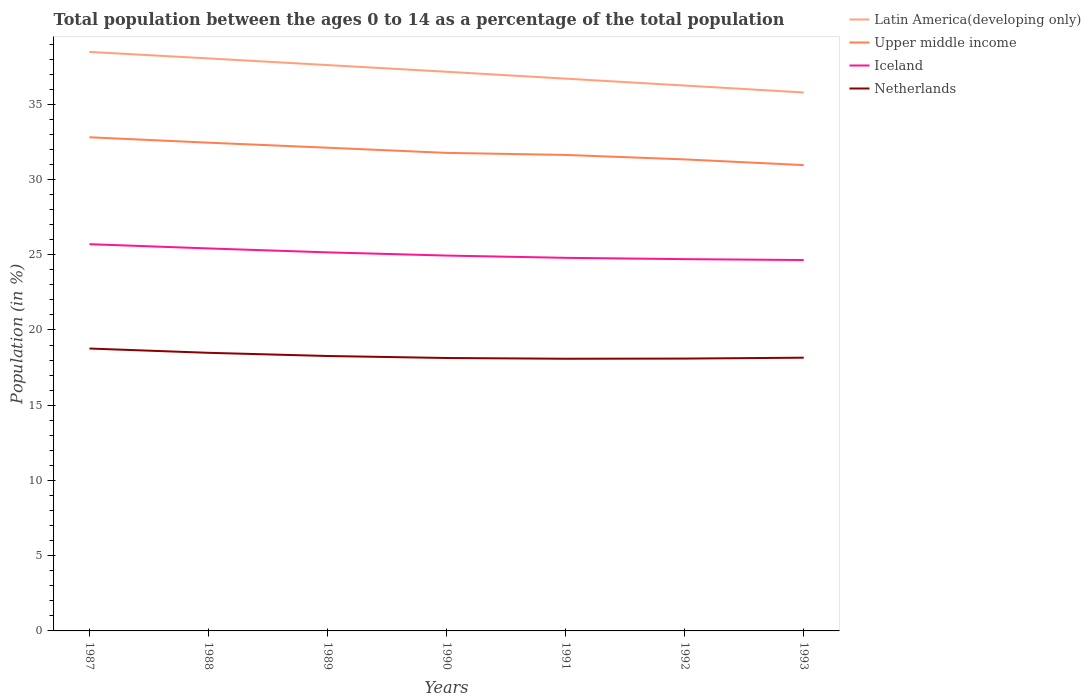Does the line corresponding to Latin America(developing only) intersect with the line corresponding to Iceland?
Offer a terse response. No. Is the number of lines equal to the number of legend labels?
Keep it short and to the point. Yes. Across all years, what is the maximum percentage of the population ages 0 to 14 in Netherlands?
Your response must be concise. 18.09. What is the total percentage of the population ages 0 to 14 in Iceland in the graph?
Ensure brevity in your answer.  0.21. What is the difference between the highest and the second highest percentage of the population ages 0 to 14 in Iceland?
Give a very brief answer. 1.05. Is the percentage of the population ages 0 to 14 in Iceland strictly greater than the percentage of the population ages 0 to 14 in Latin America(developing only) over the years?
Ensure brevity in your answer.  Yes. How many years are there in the graph?
Make the answer very short. 7. Does the graph contain any zero values?
Your response must be concise. No. Does the graph contain grids?
Offer a terse response. No. Where does the legend appear in the graph?
Give a very brief answer. Top right. How many legend labels are there?
Your response must be concise. 4. How are the legend labels stacked?
Keep it short and to the point. Vertical. What is the title of the graph?
Ensure brevity in your answer.  Total population between the ages 0 to 14 as a percentage of the total population. Does "North America" appear as one of the legend labels in the graph?
Your answer should be very brief. No. What is the label or title of the X-axis?
Your answer should be compact. Years. What is the Population (in %) in Latin America(developing only) in 1987?
Your response must be concise. 38.48. What is the Population (in %) of Upper middle income in 1987?
Ensure brevity in your answer.  32.81. What is the Population (in %) in Iceland in 1987?
Offer a very short reply. 25.7. What is the Population (in %) of Netherlands in 1987?
Provide a short and direct response. 18.77. What is the Population (in %) of Latin America(developing only) in 1988?
Your answer should be very brief. 38.05. What is the Population (in %) in Upper middle income in 1988?
Ensure brevity in your answer.  32.45. What is the Population (in %) in Iceland in 1988?
Make the answer very short. 25.42. What is the Population (in %) in Netherlands in 1988?
Offer a terse response. 18.48. What is the Population (in %) in Latin America(developing only) in 1989?
Your answer should be compact. 37.61. What is the Population (in %) of Upper middle income in 1989?
Offer a terse response. 32.11. What is the Population (in %) of Iceland in 1989?
Your answer should be very brief. 25.16. What is the Population (in %) in Netherlands in 1989?
Offer a very short reply. 18.27. What is the Population (in %) in Latin America(developing only) in 1990?
Give a very brief answer. 37.16. What is the Population (in %) of Upper middle income in 1990?
Provide a succinct answer. 31.77. What is the Population (in %) of Iceland in 1990?
Ensure brevity in your answer.  24.95. What is the Population (in %) of Netherlands in 1990?
Provide a succinct answer. 18.14. What is the Population (in %) of Latin America(developing only) in 1991?
Give a very brief answer. 36.7. What is the Population (in %) in Upper middle income in 1991?
Give a very brief answer. 31.63. What is the Population (in %) of Iceland in 1991?
Your response must be concise. 24.79. What is the Population (in %) of Netherlands in 1991?
Provide a succinct answer. 18.09. What is the Population (in %) in Latin America(developing only) in 1992?
Offer a terse response. 36.25. What is the Population (in %) in Upper middle income in 1992?
Give a very brief answer. 31.34. What is the Population (in %) in Iceland in 1992?
Provide a succinct answer. 24.71. What is the Population (in %) in Netherlands in 1992?
Your response must be concise. 18.1. What is the Population (in %) of Latin America(developing only) in 1993?
Provide a short and direct response. 35.78. What is the Population (in %) of Upper middle income in 1993?
Offer a very short reply. 30.96. What is the Population (in %) in Iceland in 1993?
Give a very brief answer. 24.65. What is the Population (in %) in Netherlands in 1993?
Give a very brief answer. 18.16. Across all years, what is the maximum Population (in %) of Latin America(developing only)?
Your answer should be very brief. 38.48. Across all years, what is the maximum Population (in %) in Upper middle income?
Offer a very short reply. 32.81. Across all years, what is the maximum Population (in %) of Iceland?
Your answer should be very brief. 25.7. Across all years, what is the maximum Population (in %) of Netherlands?
Offer a terse response. 18.77. Across all years, what is the minimum Population (in %) of Latin America(developing only)?
Keep it short and to the point. 35.78. Across all years, what is the minimum Population (in %) in Upper middle income?
Keep it short and to the point. 30.96. Across all years, what is the minimum Population (in %) in Iceland?
Provide a succinct answer. 24.65. Across all years, what is the minimum Population (in %) in Netherlands?
Ensure brevity in your answer.  18.09. What is the total Population (in %) of Latin America(developing only) in the graph?
Your response must be concise. 260.03. What is the total Population (in %) of Upper middle income in the graph?
Ensure brevity in your answer.  223.07. What is the total Population (in %) of Iceland in the graph?
Ensure brevity in your answer.  175.38. What is the total Population (in %) of Netherlands in the graph?
Provide a succinct answer. 128.01. What is the difference between the Population (in %) in Latin America(developing only) in 1987 and that in 1988?
Your answer should be very brief. 0.43. What is the difference between the Population (in %) of Upper middle income in 1987 and that in 1988?
Offer a terse response. 0.36. What is the difference between the Population (in %) in Iceland in 1987 and that in 1988?
Your response must be concise. 0.28. What is the difference between the Population (in %) in Netherlands in 1987 and that in 1988?
Provide a short and direct response. 0.28. What is the difference between the Population (in %) of Latin America(developing only) in 1987 and that in 1989?
Keep it short and to the point. 0.87. What is the difference between the Population (in %) in Upper middle income in 1987 and that in 1989?
Offer a terse response. 0.69. What is the difference between the Population (in %) of Iceland in 1987 and that in 1989?
Make the answer very short. 0.54. What is the difference between the Population (in %) of Netherlands in 1987 and that in 1989?
Ensure brevity in your answer.  0.5. What is the difference between the Population (in %) of Latin America(developing only) in 1987 and that in 1990?
Your response must be concise. 1.32. What is the difference between the Population (in %) in Upper middle income in 1987 and that in 1990?
Provide a succinct answer. 1.04. What is the difference between the Population (in %) in Iceland in 1987 and that in 1990?
Your answer should be very brief. 0.76. What is the difference between the Population (in %) of Netherlands in 1987 and that in 1990?
Your response must be concise. 0.63. What is the difference between the Population (in %) in Latin America(developing only) in 1987 and that in 1991?
Ensure brevity in your answer.  1.78. What is the difference between the Population (in %) of Upper middle income in 1987 and that in 1991?
Give a very brief answer. 1.17. What is the difference between the Population (in %) in Iceland in 1987 and that in 1991?
Keep it short and to the point. 0.91. What is the difference between the Population (in %) of Netherlands in 1987 and that in 1991?
Provide a succinct answer. 0.68. What is the difference between the Population (in %) in Latin America(developing only) in 1987 and that in 1992?
Give a very brief answer. 2.23. What is the difference between the Population (in %) of Upper middle income in 1987 and that in 1992?
Give a very brief answer. 1.47. What is the difference between the Population (in %) in Iceland in 1987 and that in 1992?
Provide a short and direct response. 1. What is the difference between the Population (in %) in Netherlands in 1987 and that in 1992?
Ensure brevity in your answer.  0.67. What is the difference between the Population (in %) of Latin America(developing only) in 1987 and that in 1993?
Your answer should be compact. 2.7. What is the difference between the Population (in %) of Upper middle income in 1987 and that in 1993?
Provide a succinct answer. 1.85. What is the difference between the Population (in %) in Iceland in 1987 and that in 1993?
Provide a succinct answer. 1.05. What is the difference between the Population (in %) in Netherlands in 1987 and that in 1993?
Your answer should be very brief. 0.61. What is the difference between the Population (in %) of Latin America(developing only) in 1988 and that in 1989?
Offer a very short reply. 0.44. What is the difference between the Population (in %) of Upper middle income in 1988 and that in 1989?
Provide a short and direct response. 0.33. What is the difference between the Population (in %) in Iceland in 1988 and that in 1989?
Offer a very short reply. 0.26. What is the difference between the Population (in %) of Netherlands in 1988 and that in 1989?
Provide a short and direct response. 0.21. What is the difference between the Population (in %) in Latin America(developing only) in 1988 and that in 1990?
Make the answer very short. 0.89. What is the difference between the Population (in %) of Upper middle income in 1988 and that in 1990?
Your answer should be compact. 0.68. What is the difference between the Population (in %) of Iceland in 1988 and that in 1990?
Your response must be concise. 0.47. What is the difference between the Population (in %) of Netherlands in 1988 and that in 1990?
Your answer should be compact. 0.34. What is the difference between the Population (in %) of Latin America(developing only) in 1988 and that in 1991?
Keep it short and to the point. 1.34. What is the difference between the Population (in %) in Upper middle income in 1988 and that in 1991?
Provide a succinct answer. 0.82. What is the difference between the Population (in %) in Iceland in 1988 and that in 1991?
Provide a short and direct response. 0.62. What is the difference between the Population (in %) of Netherlands in 1988 and that in 1991?
Offer a terse response. 0.39. What is the difference between the Population (in %) in Latin America(developing only) in 1988 and that in 1992?
Ensure brevity in your answer.  1.8. What is the difference between the Population (in %) in Upper middle income in 1988 and that in 1992?
Ensure brevity in your answer.  1.11. What is the difference between the Population (in %) in Iceland in 1988 and that in 1992?
Provide a succinct answer. 0.71. What is the difference between the Population (in %) in Netherlands in 1988 and that in 1992?
Ensure brevity in your answer.  0.38. What is the difference between the Population (in %) of Latin America(developing only) in 1988 and that in 1993?
Provide a short and direct response. 2.26. What is the difference between the Population (in %) of Upper middle income in 1988 and that in 1993?
Give a very brief answer. 1.49. What is the difference between the Population (in %) in Iceland in 1988 and that in 1993?
Offer a very short reply. 0.77. What is the difference between the Population (in %) in Netherlands in 1988 and that in 1993?
Keep it short and to the point. 0.32. What is the difference between the Population (in %) in Latin America(developing only) in 1989 and that in 1990?
Provide a succinct answer. 0.44. What is the difference between the Population (in %) in Upper middle income in 1989 and that in 1990?
Keep it short and to the point. 0.34. What is the difference between the Population (in %) of Iceland in 1989 and that in 1990?
Make the answer very short. 0.21. What is the difference between the Population (in %) of Netherlands in 1989 and that in 1990?
Provide a succinct answer. 0.13. What is the difference between the Population (in %) of Latin America(developing only) in 1989 and that in 1991?
Provide a succinct answer. 0.9. What is the difference between the Population (in %) of Upper middle income in 1989 and that in 1991?
Your answer should be compact. 0.48. What is the difference between the Population (in %) in Iceland in 1989 and that in 1991?
Your answer should be very brief. 0.36. What is the difference between the Population (in %) in Netherlands in 1989 and that in 1991?
Your answer should be compact. 0.18. What is the difference between the Population (in %) in Latin America(developing only) in 1989 and that in 1992?
Give a very brief answer. 1.36. What is the difference between the Population (in %) of Upper middle income in 1989 and that in 1992?
Provide a succinct answer. 0.78. What is the difference between the Population (in %) of Iceland in 1989 and that in 1992?
Ensure brevity in your answer.  0.45. What is the difference between the Population (in %) in Netherlands in 1989 and that in 1992?
Keep it short and to the point. 0.17. What is the difference between the Population (in %) in Latin America(developing only) in 1989 and that in 1993?
Your answer should be very brief. 1.82. What is the difference between the Population (in %) of Upper middle income in 1989 and that in 1993?
Ensure brevity in your answer.  1.16. What is the difference between the Population (in %) of Iceland in 1989 and that in 1993?
Your answer should be compact. 0.51. What is the difference between the Population (in %) of Netherlands in 1989 and that in 1993?
Ensure brevity in your answer.  0.11. What is the difference between the Population (in %) in Latin America(developing only) in 1990 and that in 1991?
Make the answer very short. 0.46. What is the difference between the Population (in %) in Upper middle income in 1990 and that in 1991?
Your answer should be compact. 0.14. What is the difference between the Population (in %) in Iceland in 1990 and that in 1991?
Keep it short and to the point. 0.15. What is the difference between the Population (in %) of Netherlands in 1990 and that in 1991?
Your answer should be very brief. 0.05. What is the difference between the Population (in %) in Latin America(developing only) in 1990 and that in 1992?
Make the answer very short. 0.92. What is the difference between the Population (in %) in Upper middle income in 1990 and that in 1992?
Your answer should be compact. 0.43. What is the difference between the Population (in %) in Iceland in 1990 and that in 1992?
Offer a very short reply. 0.24. What is the difference between the Population (in %) of Netherlands in 1990 and that in 1992?
Make the answer very short. 0.04. What is the difference between the Population (in %) in Latin America(developing only) in 1990 and that in 1993?
Ensure brevity in your answer.  1.38. What is the difference between the Population (in %) of Upper middle income in 1990 and that in 1993?
Offer a very short reply. 0.81. What is the difference between the Population (in %) of Iceland in 1990 and that in 1993?
Offer a very short reply. 0.3. What is the difference between the Population (in %) in Netherlands in 1990 and that in 1993?
Offer a very short reply. -0.02. What is the difference between the Population (in %) of Latin America(developing only) in 1991 and that in 1992?
Your answer should be compact. 0.46. What is the difference between the Population (in %) in Upper middle income in 1991 and that in 1992?
Offer a terse response. 0.3. What is the difference between the Population (in %) in Iceland in 1991 and that in 1992?
Offer a very short reply. 0.09. What is the difference between the Population (in %) of Netherlands in 1991 and that in 1992?
Provide a short and direct response. -0.01. What is the difference between the Population (in %) of Latin America(developing only) in 1991 and that in 1993?
Give a very brief answer. 0.92. What is the difference between the Population (in %) in Upper middle income in 1991 and that in 1993?
Your answer should be very brief. 0.67. What is the difference between the Population (in %) of Iceland in 1991 and that in 1993?
Give a very brief answer. 0.15. What is the difference between the Population (in %) of Netherlands in 1991 and that in 1993?
Your response must be concise. -0.07. What is the difference between the Population (in %) of Latin America(developing only) in 1992 and that in 1993?
Your answer should be compact. 0.46. What is the difference between the Population (in %) in Upper middle income in 1992 and that in 1993?
Ensure brevity in your answer.  0.38. What is the difference between the Population (in %) of Iceland in 1992 and that in 1993?
Your answer should be very brief. 0.06. What is the difference between the Population (in %) of Netherlands in 1992 and that in 1993?
Provide a short and direct response. -0.06. What is the difference between the Population (in %) of Latin America(developing only) in 1987 and the Population (in %) of Upper middle income in 1988?
Give a very brief answer. 6.03. What is the difference between the Population (in %) in Latin America(developing only) in 1987 and the Population (in %) in Iceland in 1988?
Offer a terse response. 13.06. What is the difference between the Population (in %) of Latin America(developing only) in 1987 and the Population (in %) of Netherlands in 1988?
Provide a short and direct response. 20. What is the difference between the Population (in %) of Upper middle income in 1987 and the Population (in %) of Iceland in 1988?
Your answer should be very brief. 7.39. What is the difference between the Population (in %) in Upper middle income in 1987 and the Population (in %) in Netherlands in 1988?
Your answer should be very brief. 14.32. What is the difference between the Population (in %) in Iceland in 1987 and the Population (in %) in Netherlands in 1988?
Ensure brevity in your answer.  7.22. What is the difference between the Population (in %) of Latin America(developing only) in 1987 and the Population (in %) of Upper middle income in 1989?
Your response must be concise. 6.37. What is the difference between the Population (in %) of Latin America(developing only) in 1987 and the Population (in %) of Iceland in 1989?
Offer a very short reply. 13.32. What is the difference between the Population (in %) in Latin America(developing only) in 1987 and the Population (in %) in Netherlands in 1989?
Give a very brief answer. 20.21. What is the difference between the Population (in %) of Upper middle income in 1987 and the Population (in %) of Iceland in 1989?
Keep it short and to the point. 7.65. What is the difference between the Population (in %) of Upper middle income in 1987 and the Population (in %) of Netherlands in 1989?
Your response must be concise. 14.54. What is the difference between the Population (in %) in Iceland in 1987 and the Population (in %) in Netherlands in 1989?
Keep it short and to the point. 7.43. What is the difference between the Population (in %) in Latin America(developing only) in 1987 and the Population (in %) in Upper middle income in 1990?
Your response must be concise. 6.71. What is the difference between the Population (in %) of Latin America(developing only) in 1987 and the Population (in %) of Iceland in 1990?
Make the answer very short. 13.53. What is the difference between the Population (in %) in Latin America(developing only) in 1987 and the Population (in %) in Netherlands in 1990?
Give a very brief answer. 20.34. What is the difference between the Population (in %) in Upper middle income in 1987 and the Population (in %) in Iceland in 1990?
Provide a short and direct response. 7.86. What is the difference between the Population (in %) in Upper middle income in 1987 and the Population (in %) in Netherlands in 1990?
Keep it short and to the point. 14.67. What is the difference between the Population (in %) in Iceland in 1987 and the Population (in %) in Netherlands in 1990?
Ensure brevity in your answer.  7.56. What is the difference between the Population (in %) in Latin America(developing only) in 1987 and the Population (in %) in Upper middle income in 1991?
Ensure brevity in your answer.  6.85. What is the difference between the Population (in %) of Latin America(developing only) in 1987 and the Population (in %) of Iceland in 1991?
Ensure brevity in your answer.  13.69. What is the difference between the Population (in %) of Latin America(developing only) in 1987 and the Population (in %) of Netherlands in 1991?
Keep it short and to the point. 20.39. What is the difference between the Population (in %) in Upper middle income in 1987 and the Population (in %) in Iceland in 1991?
Provide a succinct answer. 8.01. What is the difference between the Population (in %) in Upper middle income in 1987 and the Population (in %) in Netherlands in 1991?
Give a very brief answer. 14.72. What is the difference between the Population (in %) of Iceland in 1987 and the Population (in %) of Netherlands in 1991?
Your answer should be very brief. 7.61. What is the difference between the Population (in %) in Latin America(developing only) in 1987 and the Population (in %) in Upper middle income in 1992?
Offer a terse response. 7.14. What is the difference between the Population (in %) of Latin America(developing only) in 1987 and the Population (in %) of Iceland in 1992?
Your answer should be very brief. 13.77. What is the difference between the Population (in %) in Latin America(developing only) in 1987 and the Population (in %) in Netherlands in 1992?
Provide a succinct answer. 20.38. What is the difference between the Population (in %) in Upper middle income in 1987 and the Population (in %) in Iceland in 1992?
Your answer should be very brief. 8.1. What is the difference between the Population (in %) of Upper middle income in 1987 and the Population (in %) of Netherlands in 1992?
Provide a succinct answer. 14.71. What is the difference between the Population (in %) of Iceland in 1987 and the Population (in %) of Netherlands in 1992?
Offer a terse response. 7.6. What is the difference between the Population (in %) in Latin America(developing only) in 1987 and the Population (in %) in Upper middle income in 1993?
Provide a succinct answer. 7.52. What is the difference between the Population (in %) of Latin America(developing only) in 1987 and the Population (in %) of Iceland in 1993?
Your answer should be very brief. 13.83. What is the difference between the Population (in %) in Latin America(developing only) in 1987 and the Population (in %) in Netherlands in 1993?
Offer a terse response. 20.32. What is the difference between the Population (in %) in Upper middle income in 1987 and the Population (in %) in Iceland in 1993?
Offer a terse response. 8.16. What is the difference between the Population (in %) in Upper middle income in 1987 and the Population (in %) in Netherlands in 1993?
Give a very brief answer. 14.65. What is the difference between the Population (in %) in Iceland in 1987 and the Population (in %) in Netherlands in 1993?
Keep it short and to the point. 7.54. What is the difference between the Population (in %) in Latin America(developing only) in 1988 and the Population (in %) in Upper middle income in 1989?
Provide a short and direct response. 5.93. What is the difference between the Population (in %) in Latin America(developing only) in 1988 and the Population (in %) in Iceland in 1989?
Keep it short and to the point. 12.89. What is the difference between the Population (in %) in Latin America(developing only) in 1988 and the Population (in %) in Netherlands in 1989?
Provide a succinct answer. 19.78. What is the difference between the Population (in %) of Upper middle income in 1988 and the Population (in %) of Iceland in 1989?
Offer a terse response. 7.29. What is the difference between the Population (in %) of Upper middle income in 1988 and the Population (in %) of Netherlands in 1989?
Give a very brief answer. 14.18. What is the difference between the Population (in %) in Iceland in 1988 and the Population (in %) in Netherlands in 1989?
Provide a short and direct response. 7.15. What is the difference between the Population (in %) of Latin America(developing only) in 1988 and the Population (in %) of Upper middle income in 1990?
Make the answer very short. 6.28. What is the difference between the Population (in %) of Latin America(developing only) in 1988 and the Population (in %) of Iceland in 1990?
Ensure brevity in your answer.  13.1. What is the difference between the Population (in %) in Latin America(developing only) in 1988 and the Population (in %) in Netherlands in 1990?
Your answer should be compact. 19.91. What is the difference between the Population (in %) in Upper middle income in 1988 and the Population (in %) in Iceland in 1990?
Your answer should be very brief. 7.5. What is the difference between the Population (in %) in Upper middle income in 1988 and the Population (in %) in Netherlands in 1990?
Your answer should be compact. 14.31. What is the difference between the Population (in %) in Iceland in 1988 and the Population (in %) in Netherlands in 1990?
Provide a short and direct response. 7.28. What is the difference between the Population (in %) in Latin America(developing only) in 1988 and the Population (in %) in Upper middle income in 1991?
Your answer should be very brief. 6.42. What is the difference between the Population (in %) in Latin America(developing only) in 1988 and the Population (in %) in Iceland in 1991?
Your response must be concise. 13.25. What is the difference between the Population (in %) of Latin America(developing only) in 1988 and the Population (in %) of Netherlands in 1991?
Ensure brevity in your answer.  19.96. What is the difference between the Population (in %) in Upper middle income in 1988 and the Population (in %) in Iceland in 1991?
Provide a short and direct response. 7.65. What is the difference between the Population (in %) in Upper middle income in 1988 and the Population (in %) in Netherlands in 1991?
Your response must be concise. 14.36. What is the difference between the Population (in %) of Iceland in 1988 and the Population (in %) of Netherlands in 1991?
Your answer should be very brief. 7.33. What is the difference between the Population (in %) of Latin America(developing only) in 1988 and the Population (in %) of Upper middle income in 1992?
Your response must be concise. 6.71. What is the difference between the Population (in %) in Latin America(developing only) in 1988 and the Population (in %) in Iceland in 1992?
Provide a succinct answer. 13.34. What is the difference between the Population (in %) in Latin America(developing only) in 1988 and the Population (in %) in Netherlands in 1992?
Provide a short and direct response. 19.95. What is the difference between the Population (in %) of Upper middle income in 1988 and the Population (in %) of Iceland in 1992?
Make the answer very short. 7.74. What is the difference between the Population (in %) in Upper middle income in 1988 and the Population (in %) in Netherlands in 1992?
Give a very brief answer. 14.35. What is the difference between the Population (in %) of Iceland in 1988 and the Population (in %) of Netherlands in 1992?
Offer a very short reply. 7.32. What is the difference between the Population (in %) of Latin America(developing only) in 1988 and the Population (in %) of Upper middle income in 1993?
Keep it short and to the point. 7.09. What is the difference between the Population (in %) of Latin America(developing only) in 1988 and the Population (in %) of Iceland in 1993?
Ensure brevity in your answer.  13.4. What is the difference between the Population (in %) of Latin America(developing only) in 1988 and the Population (in %) of Netherlands in 1993?
Your response must be concise. 19.89. What is the difference between the Population (in %) of Upper middle income in 1988 and the Population (in %) of Iceland in 1993?
Your answer should be very brief. 7.8. What is the difference between the Population (in %) in Upper middle income in 1988 and the Population (in %) in Netherlands in 1993?
Your answer should be very brief. 14.29. What is the difference between the Population (in %) in Iceland in 1988 and the Population (in %) in Netherlands in 1993?
Provide a succinct answer. 7.26. What is the difference between the Population (in %) in Latin America(developing only) in 1989 and the Population (in %) in Upper middle income in 1990?
Provide a succinct answer. 5.84. What is the difference between the Population (in %) of Latin America(developing only) in 1989 and the Population (in %) of Iceland in 1990?
Your response must be concise. 12.66. What is the difference between the Population (in %) of Latin America(developing only) in 1989 and the Population (in %) of Netherlands in 1990?
Ensure brevity in your answer.  19.47. What is the difference between the Population (in %) in Upper middle income in 1989 and the Population (in %) in Iceland in 1990?
Give a very brief answer. 7.17. What is the difference between the Population (in %) in Upper middle income in 1989 and the Population (in %) in Netherlands in 1990?
Provide a succinct answer. 13.98. What is the difference between the Population (in %) in Iceland in 1989 and the Population (in %) in Netherlands in 1990?
Your answer should be very brief. 7.02. What is the difference between the Population (in %) in Latin America(developing only) in 1989 and the Population (in %) in Upper middle income in 1991?
Keep it short and to the point. 5.97. What is the difference between the Population (in %) in Latin America(developing only) in 1989 and the Population (in %) in Iceland in 1991?
Provide a succinct answer. 12.81. What is the difference between the Population (in %) in Latin America(developing only) in 1989 and the Population (in %) in Netherlands in 1991?
Your response must be concise. 19.52. What is the difference between the Population (in %) in Upper middle income in 1989 and the Population (in %) in Iceland in 1991?
Keep it short and to the point. 7.32. What is the difference between the Population (in %) in Upper middle income in 1989 and the Population (in %) in Netherlands in 1991?
Offer a terse response. 14.03. What is the difference between the Population (in %) of Iceland in 1989 and the Population (in %) of Netherlands in 1991?
Offer a terse response. 7.07. What is the difference between the Population (in %) of Latin America(developing only) in 1989 and the Population (in %) of Upper middle income in 1992?
Your answer should be very brief. 6.27. What is the difference between the Population (in %) of Latin America(developing only) in 1989 and the Population (in %) of Iceland in 1992?
Make the answer very short. 12.9. What is the difference between the Population (in %) of Latin America(developing only) in 1989 and the Population (in %) of Netherlands in 1992?
Offer a very short reply. 19.51. What is the difference between the Population (in %) of Upper middle income in 1989 and the Population (in %) of Iceland in 1992?
Ensure brevity in your answer.  7.41. What is the difference between the Population (in %) of Upper middle income in 1989 and the Population (in %) of Netherlands in 1992?
Your answer should be compact. 14.01. What is the difference between the Population (in %) in Iceland in 1989 and the Population (in %) in Netherlands in 1992?
Make the answer very short. 7.06. What is the difference between the Population (in %) in Latin America(developing only) in 1989 and the Population (in %) in Upper middle income in 1993?
Give a very brief answer. 6.65. What is the difference between the Population (in %) in Latin America(developing only) in 1989 and the Population (in %) in Iceland in 1993?
Provide a short and direct response. 12.96. What is the difference between the Population (in %) of Latin America(developing only) in 1989 and the Population (in %) of Netherlands in 1993?
Ensure brevity in your answer.  19.45. What is the difference between the Population (in %) of Upper middle income in 1989 and the Population (in %) of Iceland in 1993?
Your answer should be very brief. 7.46. What is the difference between the Population (in %) in Upper middle income in 1989 and the Population (in %) in Netherlands in 1993?
Make the answer very short. 13.96. What is the difference between the Population (in %) in Iceland in 1989 and the Population (in %) in Netherlands in 1993?
Ensure brevity in your answer.  7. What is the difference between the Population (in %) in Latin America(developing only) in 1990 and the Population (in %) in Upper middle income in 1991?
Provide a short and direct response. 5.53. What is the difference between the Population (in %) in Latin America(developing only) in 1990 and the Population (in %) in Iceland in 1991?
Your answer should be compact. 12.37. What is the difference between the Population (in %) in Latin America(developing only) in 1990 and the Population (in %) in Netherlands in 1991?
Make the answer very short. 19.07. What is the difference between the Population (in %) in Upper middle income in 1990 and the Population (in %) in Iceland in 1991?
Your response must be concise. 6.98. What is the difference between the Population (in %) in Upper middle income in 1990 and the Population (in %) in Netherlands in 1991?
Provide a succinct answer. 13.68. What is the difference between the Population (in %) in Iceland in 1990 and the Population (in %) in Netherlands in 1991?
Make the answer very short. 6.86. What is the difference between the Population (in %) of Latin America(developing only) in 1990 and the Population (in %) of Upper middle income in 1992?
Give a very brief answer. 5.82. What is the difference between the Population (in %) of Latin America(developing only) in 1990 and the Population (in %) of Iceland in 1992?
Ensure brevity in your answer.  12.45. What is the difference between the Population (in %) of Latin America(developing only) in 1990 and the Population (in %) of Netherlands in 1992?
Your response must be concise. 19.06. What is the difference between the Population (in %) in Upper middle income in 1990 and the Population (in %) in Iceland in 1992?
Make the answer very short. 7.06. What is the difference between the Population (in %) in Upper middle income in 1990 and the Population (in %) in Netherlands in 1992?
Offer a very short reply. 13.67. What is the difference between the Population (in %) of Iceland in 1990 and the Population (in %) of Netherlands in 1992?
Your answer should be very brief. 6.85. What is the difference between the Population (in %) of Latin America(developing only) in 1990 and the Population (in %) of Upper middle income in 1993?
Provide a succinct answer. 6.2. What is the difference between the Population (in %) in Latin America(developing only) in 1990 and the Population (in %) in Iceland in 1993?
Your response must be concise. 12.51. What is the difference between the Population (in %) of Latin America(developing only) in 1990 and the Population (in %) of Netherlands in 1993?
Your answer should be compact. 19. What is the difference between the Population (in %) in Upper middle income in 1990 and the Population (in %) in Iceland in 1993?
Make the answer very short. 7.12. What is the difference between the Population (in %) of Upper middle income in 1990 and the Population (in %) of Netherlands in 1993?
Offer a terse response. 13.61. What is the difference between the Population (in %) of Iceland in 1990 and the Population (in %) of Netherlands in 1993?
Provide a short and direct response. 6.79. What is the difference between the Population (in %) of Latin America(developing only) in 1991 and the Population (in %) of Upper middle income in 1992?
Provide a short and direct response. 5.37. What is the difference between the Population (in %) of Latin America(developing only) in 1991 and the Population (in %) of Iceland in 1992?
Ensure brevity in your answer.  12. What is the difference between the Population (in %) in Latin America(developing only) in 1991 and the Population (in %) in Netherlands in 1992?
Make the answer very short. 18.6. What is the difference between the Population (in %) of Upper middle income in 1991 and the Population (in %) of Iceland in 1992?
Your answer should be compact. 6.92. What is the difference between the Population (in %) of Upper middle income in 1991 and the Population (in %) of Netherlands in 1992?
Offer a terse response. 13.53. What is the difference between the Population (in %) in Iceland in 1991 and the Population (in %) in Netherlands in 1992?
Your response must be concise. 6.7. What is the difference between the Population (in %) in Latin America(developing only) in 1991 and the Population (in %) in Upper middle income in 1993?
Offer a very short reply. 5.75. What is the difference between the Population (in %) in Latin America(developing only) in 1991 and the Population (in %) in Iceland in 1993?
Your response must be concise. 12.05. What is the difference between the Population (in %) of Latin America(developing only) in 1991 and the Population (in %) of Netherlands in 1993?
Make the answer very short. 18.55. What is the difference between the Population (in %) in Upper middle income in 1991 and the Population (in %) in Iceland in 1993?
Your answer should be very brief. 6.98. What is the difference between the Population (in %) in Upper middle income in 1991 and the Population (in %) in Netherlands in 1993?
Your answer should be very brief. 13.47. What is the difference between the Population (in %) in Iceland in 1991 and the Population (in %) in Netherlands in 1993?
Your response must be concise. 6.64. What is the difference between the Population (in %) in Latin America(developing only) in 1992 and the Population (in %) in Upper middle income in 1993?
Offer a terse response. 5.29. What is the difference between the Population (in %) of Latin America(developing only) in 1992 and the Population (in %) of Iceland in 1993?
Offer a terse response. 11.6. What is the difference between the Population (in %) in Latin America(developing only) in 1992 and the Population (in %) in Netherlands in 1993?
Offer a terse response. 18.09. What is the difference between the Population (in %) in Upper middle income in 1992 and the Population (in %) in Iceland in 1993?
Your answer should be very brief. 6.69. What is the difference between the Population (in %) of Upper middle income in 1992 and the Population (in %) of Netherlands in 1993?
Ensure brevity in your answer.  13.18. What is the difference between the Population (in %) in Iceland in 1992 and the Population (in %) in Netherlands in 1993?
Keep it short and to the point. 6.55. What is the average Population (in %) of Latin America(developing only) per year?
Offer a very short reply. 37.15. What is the average Population (in %) in Upper middle income per year?
Your answer should be compact. 31.87. What is the average Population (in %) of Iceland per year?
Offer a very short reply. 25.05. What is the average Population (in %) of Netherlands per year?
Keep it short and to the point. 18.29. In the year 1987, what is the difference between the Population (in %) of Latin America(developing only) and Population (in %) of Upper middle income?
Make the answer very short. 5.67. In the year 1987, what is the difference between the Population (in %) of Latin America(developing only) and Population (in %) of Iceland?
Keep it short and to the point. 12.78. In the year 1987, what is the difference between the Population (in %) of Latin America(developing only) and Population (in %) of Netherlands?
Your response must be concise. 19.71. In the year 1987, what is the difference between the Population (in %) in Upper middle income and Population (in %) in Iceland?
Provide a succinct answer. 7.1. In the year 1987, what is the difference between the Population (in %) in Upper middle income and Population (in %) in Netherlands?
Your answer should be very brief. 14.04. In the year 1987, what is the difference between the Population (in %) of Iceland and Population (in %) of Netherlands?
Keep it short and to the point. 6.94. In the year 1988, what is the difference between the Population (in %) in Latin America(developing only) and Population (in %) in Upper middle income?
Your response must be concise. 5.6. In the year 1988, what is the difference between the Population (in %) of Latin America(developing only) and Population (in %) of Iceland?
Give a very brief answer. 12.63. In the year 1988, what is the difference between the Population (in %) of Latin America(developing only) and Population (in %) of Netherlands?
Give a very brief answer. 19.57. In the year 1988, what is the difference between the Population (in %) in Upper middle income and Population (in %) in Iceland?
Your response must be concise. 7.03. In the year 1988, what is the difference between the Population (in %) in Upper middle income and Population (in %) in Netherlands?
Keep it short and to the point. 13.97. In the year 1988, what is the difference between the Population (in %) in Iceland and Population (in %) in Netherlands?
Make the answer very short. 6.94. In the year 1989, what is the difference between the Population (in %) in Latin America(developing only) and Population (in %) in Upper middle income?
Make the answer very short. 5.49. In the year 1989, what is the difference between the Population (in %) of Latin America(developing only) and Population (in %) of Iceland?
Offer a terse response. 12.45. In the year 1989, what is the difference between the Population (in %) of Latin America(developing only) and Population (in %) of Netherlands?
Your answer should be very brief. 19.34. In the year 1989, what is the difference between the Population (in %) of Upper middle income and Population (in %) of Iceland?
Make the answer very short. 6.96. In the year 1989, what is the difference between the Population (in %) of Upper middle income and Population (in %) of Netherlands?
Offer a very short reply. 13.84. In the year 1989, what is the difference between the Population (in %) in Iceland and Population (in %) in Netherlands?
Your answer should be very brief. 6.89. In the year 1990, what is the difference between the Population (in %) of Latin America(developing only) and Population (in %) of Upper middle income?
Your answer should be very brief. 5.39. In the year 1990, what is the difference between the Population (in %) of Latin America(developing only) and Population (in %) of Iceland?
Provide a succinct answer. 12.22. In the year 1990, what is the difference between the Population (in %) in Latin America(developing only) and Population (in %) in Netherlands?
Ensure brevity in your answer.  19.02. In the year 1990, what is the difference between the Population (in %) in Upper middle income and Population (in %) in Iceland?
Make the answer very short. 6.82. In the year 1990, what is the difference between the Population (in %) in Upper middle income and Population (in %) in Netherlands?
Provide a short and direct response. 13.63. In the year 1990, what is the difference between the Population (in %) in Iceland and Population (in %) in Netherlands?
Provide a succinct answer. 6.81. In the year 1991, what is the difference between the Population (in %) in Latin America(developing only) and Population (in %) in Upper middle income?
Provide a short and direct response. 5.07. In the year 1991, what is the difference between the Population (in %) in Latin America(developing only) and Population (in %) in Iceland?
Offer a very short reply. 11.91. In the year 1991, what is the difference between the Population (in %) of Latin America(developing only) and Population (in %) of Netherlands?
Keep it short and to the point. 18.62. In the year 1991, what is the difference between the Population (in %) of Upper middle income and Population (in %) of Iceland?
Your response must be concise. 6.84. In the year 1991, what is the difference between the Population (in %) in Upper middle income and Population (in %) in Netherlands?
Offer a terse response. 13.54. In the year 1991, what is the difference between the Population (in %) in Iceland and Population (in %) in Netherlands?
Your answer should be compact. 6.71. In the year 1992, what is the difference between the Population (in %) of Latin America(developing only) and Population (in %) of Upper middle income?
Your answer should be compact. 4.91. In the year 1992, what is the difference between the Population (in %) of Latin America(developing only) and Population (in %) of Iceland?
Your answer should be compact. 11.54. In the year 1992, what is the difference between the Population (in %) in Latin America(developing only) and Population (in %) in Netherlands?
Your response must be concise. 18.15. In the year 1992, what is the difference between the Population (in %) in Upper middle income and Population (in %) in Iceland?
Provide a short and direct response. 6.63. In the year 1992, what is the difference between the Population (in %) in Upper middle income and Population (in %) in Netherlands?
Ensure brevity in your answer.  13.24. In the year 1992, what is the difference between the Population (in %) in Iceland and Population (in %) in Netherlands?
Offer a terse response. 6.61. In the year 1993, what is the difference between the Population (in %) of Latin America(developing only) and Population (in %) of Upper middle income?
Your answer should be compact. 4.83. In the year 1993, what is the difference between the Population (in %) of Latin America(developing only) and Population (in %) of Iceland?
Your response must be concise. 11.13. In the year 1993, what is the difference between the Population (in %) in Latin America(developing only) and Population (in %) in Netherlands?
Give a very brief answer. 17.62. In the year 1993, what is the difference between the Population (in %) of Upper middle income and Population (in %) of Iceland?
Give a very brief answer. 6.31. In the year 1993, what is the difference between the Population (in %) in Upper middle income and Population (in %) in Netherlands?
Your answer should be compact. 12.8. In the year 1993, what is the difference between the Population (in %) of Iceland and Population (in %) of Netherlands?
Keep it short and to the point. 6.49. What is the ratio of the Population (in %) of Latin America(developing only) in 1987 to that in 1988?
Provide a short and direct response. 1.01. What is the ratio of the Population (in %) in Iceland in 1987 to that in 1988?
Your response must be concise. 1.01. What is the ratio of the Population (in %) in Netherlands in 1987 to that in 1988?
Give a very brief answer. 1.02. What is the ratio of the Population (in %) in Latin America(developing only) in 1987 to that in 1989?
Keep it short and to the point. 1.02. What is the ratio of the Population (in %) of Upper middle income in 1987 to that in 1989?
Provide a succinct answer. 1.02. What is the ratio of the Population (in %) in Iceland in 1987 to that in 1989?
Provide a succinct answer. 1.02. What is the ratio of the Population (in %) in Netherlands in 1987 to that in 1989?
Keep it short and to the point. 1.03. What is the ratio of the Population (in %) in Latin America(developing only) in 1987 to that in 1990?
Provide a short and direct response. 1.04. What is the ratio of the Population (in %) of Upper middle income in 1987 to that in 1990?
Your response must be concise. 1.03. What is the ratio of the Population (in %) in Iceland in 1987 to that in 1990?
Provide a succinct answer. 1.03. What is the ratio of the Population (in %) of Netherlands in 1987 to that in 1990?
Offer a very short reply. 1.03. What is the ratio of the Population (in %) of Latin America(developing only) in 1987 to that in 1991?
Offer a terse response. 1.05. What is the ratio of the Population (in %) in Upper middle income in 1987 to that in 1991?
Offer a terse response. 1.04. What is the ratio of the Population (in %) in Iceland in 1987 to that in 1991?
Your answer should be compact. 1.04. What is the ratio of the Population (in %) of Netherlands in 1987 to that in 1991?
Your answer should be compact. 1.04. What is the ratio of the Population (in %) of Latin America(developing only) in 1987 to that in 1992?
Ensure brevity in your answer.  1.06. What is the ratio of the Population (in %) of Upper middle income in 1987 to that in 1992?
Offer a terse response. 1.05. What is the ratio of the Population (in %) in Iceland in 1987 to that in 1992?
Your answer should be very brief. 1.04. What is the ratio of the Population (in %) of Netherlands in 1987 to that in 1992?
Your response must be concise. 1.04. What is the ratio of the Population (in %) of Latin America(developing only) in 1987 to that in 1993?
Offer a terse response. 1.08. What is the ratio of the Population (in %) of Upper middle income in 1987 to that in 1993?
Offer a terse response. 1.06. What is the ratio of the Population (in %) in Iceland in 1987 to that in 1993?
Provide a short and direct response. 1.04. What is the ratio of the Population (in %) in Netherlands in 1987 to that in 1993?
Make the answer very short. 1.03. What is the ratio of the Population (in %) in Latin America(developing only) in 1988 to that in 1989?
Offer a very short reply. 1.01. What is the ratio of the Population (in %) in Upper middle income in 1988 to that in 1989?
Provide a short and direct response. 1.01. What is the ratio of the Population (in %) in Iceland in 1988 to that in 1989?
Provide a short and direct response. 1.01. What is the ratio of the Population (in %) of Netherlands in 1988 to that in 1989?
Provide a succinct answer. 1.01. What is the ratio of the Population (in %) in Latin America(developing only) in 1988 to that in 1990?
Keep it short and to the point. 1.02. What is the ratio of the Population (in %) in Upper middle income in 1988 to that in 1990?
Your answer should be compact. 1.02. What is the ratio of the Population (in %) of Iceland in 1988 to that in 1990?
Offer a very short reply. 1.02. What is the ratio of the Population (in %) in Netherlands in 1988 to that in 1990?
Ensure brevity in your answer.  1.02. What is the ratio of the Population (in %) of Latin America(developing only) in 1988 to that in 1991?
Keep it short and to the point. 1.04. What is the ratio of the Population (in %) of Upper middle income in 1988 to that in 1991?
Your answer should be very brief. 1.03. What is the ratio of the Population (in %) of Iceland in 1988 to that in 1991?
Your answer should be very brief. 1.03. What is the ratio of the Population (in %) of Netherlands in 1988 to that in 1991?
Offer a very short reply. 1.02. What is the ratio of the Population (in %) of Latin America(developing only) in 1988 to that in 1992?
Offer a very short reply. 1.05. What is the ratio of the Population (in %) in Upper middle income in 1988 to that in 1992?
Offer a very short reply. 1.04. What is the ratio of the Population (in %) in Iceland in 1988 to that in 1992?
Your response must be concise. 1.03. What is the ratio of the Population (in %) of Netherlands in 1988 to that in 1992?
Provide a short and direct response. 1.02. What is the ratio of the Population (in %) of Latin America(developing only) in 1988 to that in 1993?
Your answer should be very brief. 1.06. What is the ratio of the Population (in %) in Upper middle income in 1988 to that in 1993?
Provide a succinct answer. 1.05. What is the ratio of the Population (in %) in Iceland in 1988 to that in 1993?
Provide a succinct answer. 1.03. What is the ratio of the Population (in %) of Netherlands in 1988 to that in 1993?
Your response must be concise. 1.02. What is the ratio of the Population (in %) in Upper middle income in 1989 to that in 1990?
Your response must be concise. 1.01. What is the ratio of the Population (in %) of Iceland in 1989 to that in 1990?
Offer a terse response. 1.01. What is the ratio of the Population (in %) of Netherlands in 1989 to that in 1990?
Give a very brief answer. 1.01. What is the ratio of the Population (in %) in Latin America(developing only) in 1989 to that in 1991?
Make the answer very short. 1.02. What is the ratio of the Population (in %) in Upper middle income in 1989 to that in 1991?
Offer a terse response. 1.02. What is the ratio of the Population (in %) of Iceland in 1989 to that in 1991?
Offer a terse response. 1.01. What is the ratio of the Population (in %) of Netherlands in 1989 to that in 1991?
Your answer should be very brief. 1.01. What is the ratio of the Population (in %) in Latin America(developing only) in 1989 to that in 1992?
Make the answer very short. 1.04. What is the ratio of the Population (in %) of Upper middle income in 1989 to that in 1992?
Your answer should be very brief. 1.02. What is the ratio of the Population (in %) of Iceland in 1989 to that in 1992?
Give a very brief answer. 1.02. What is the ratio of the Population (in %) of Netherlands in 1989 to that in 1992?
Offer a terse response. 1.01. What is the ratio of the Population (in %) in Latin America(developing only) in 1989 to that in 1993?
Your answer should be compact. 1.05. What is the ratio of the Population (in %) of Upper middle income in 1989 to that in 1993?
Keep it short and to the point. 1.04. What is the ratio of the Population (in %) of Iceland in 1989 to that in 1993?
Make the answer very short. 1.02. What is the ratio of the Population (in %) in Latin America(developing only) in 1990 to that in 1991?
Offer a terse response. 1.01. What is the ratio of the Population (in %) of Upper middle income in 1990 to that in 1991?
Keep it short and to the point. 1. What is the ratio of the Population (in %) in Iceland in 1990 to that in 1991?
Make the answer very short. 1.01. What is the ratio of the Population (in %) in Netherlands in 1990 to that in 1991?
Offer a very short reply. 1. What is the ratio of the Population (in %) in Latin America(developing only) in 1990 to that in 1992?
Provide a short and direct response. 1.03. What is the ratio of the Population (in %) of Upper middle income in 1990 to that in 1992?
Provide a succinct answer. 1.01. What is the ratio of the Population (in %) of Iceland in 1990 to that in 1992?
Ensure brevity in your answer.  1.01. What is the ratio of the Population (in %) in Upper middle income in 1990 to that in 1993?
Offer a terse response. 1.03. What is the ratio of the Population (in %) of Iceland in 1990 to that in 1993?
Your answer should be compact. 1.01. What is the ratio of the Population (in %) of Latin America(developing only) in 1991 to that in 1992?
Offer a very short reply. 1.01. What is the ratio of the Population (in %) in Upper middle income in 1991 to that in 1992?
Your answer should be compact. 1.01. What is the ratio of the Population (in %) of Latin America(developing only) in 1991 to that in 1993?
Offer a very short reply. 1.03. What is the ratio of the Population (in %) of Upper middle income in 1991 to that in 1993?
Keep it short and to the point. 1.02. What is the ratio of the Population (in %) of Iceland in 1991 to that in 1993?
Your response must be concise. 1.01. What is the ratio of the Population (in %) in Netherlands in 1991 to that in 1993?
Keep it short and to the point. 1. What is the ratio of the Population (in %) in Latin America(developing only) in 1992 to that in 1993?
Your response must be concise. 1.01. What is the ratio of the Population (in %) in Upper middle income in 1992 to that in 1993?
Give a very brief answer. 1.01. What is the ratio of the Population (in %) in Iceland in 1992 to that in 1993?
Keep it short and to the point. 1. What is the difference between the highest and the second highest Population (in %) of Latin America(developing only)?
Ensure brevity in your answer.  0.43. What is the difference between the highest and the second highest Population (in %) in Upper middle income?
Your answer should be very brief. 0.36. What is the difference between the highest and the second highest Population (in %) in Iceland?
Ensure brevity in your answer.  0.28. What is the difference between the highest and the second highest Population (in %) of Netherlands?
Keep it short and to the point. 0.28. What is the difference between the highest and the lowest Population (in %) of Latin America(developing only)?
Keep it short and to the point. 2.7. What is the difference between the highest and the lowest Population (in %) in Upper middle income?
Keep it short and to the point. 1.85. What is the difference between the highest and the lowest Population (in %) of Iceland?
Your response must be concise. 1.05. What is the difference between the highest and the lowest Population (in %) in Netherlands?
Offer a very short reply. 0.68. 